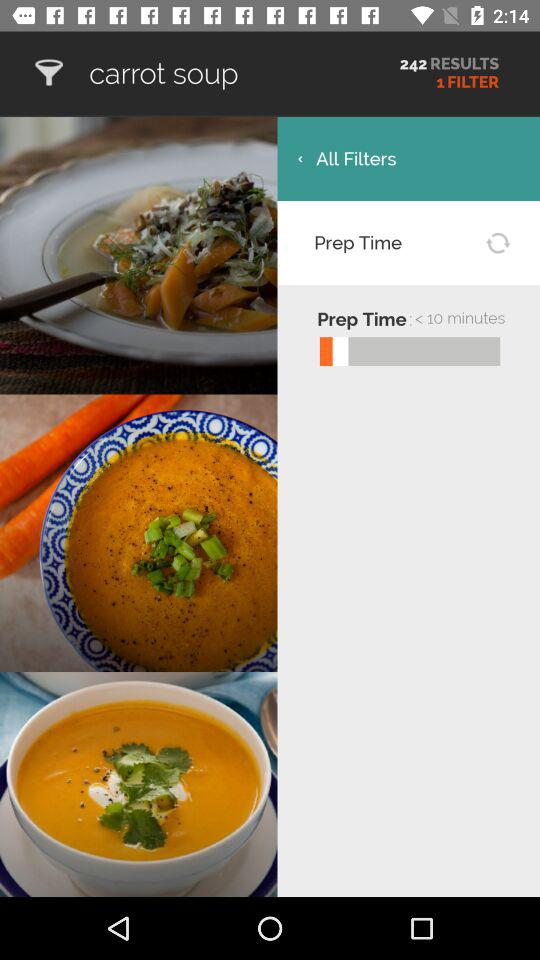How many search results are there?
Answer the question using a single word or phrase. 242 